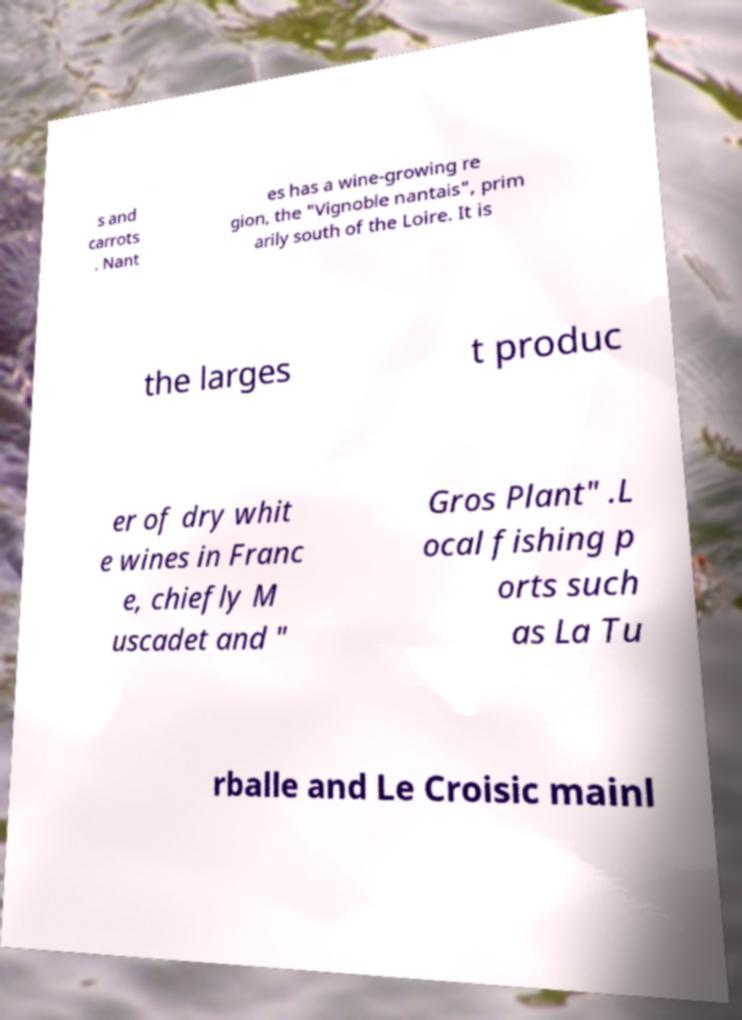I need the written content from this picture converted into text. Can you do that? s and carrots . Nant es has a wine-growing re gion, the "Vignoble nantais", prim arily south of the Loire. It is the larges t produc er of dry whit e wines in Franc e, chiefly M uscadet and " Gros Plant" .L ocal fishing p orts such as La Tu rballe and Le Croisic mainl 